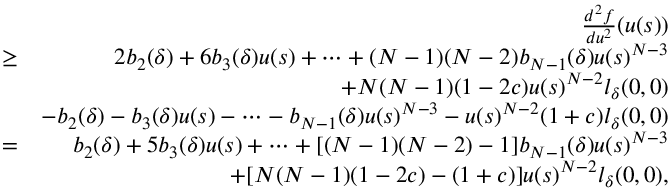Convert formula to latex. <formula><loc_0><loc_0><loc_500><loc_500>\begin{array} { r l r } & { \frac { d ^ { 2 } f } { d u ^ { 2 } } ( u ( s ) ) } \\ & { \geq } & { 2 b _ { 2 } ( \delta ) + 6 b _ { 3 } ( \delta ) u ( s ) + \cdots + ( N - 1 ) ( N - 2 ) b _ { N - 1 } ( \delta ) u ( s ) ^ { N - 3 } } \\ & { + N ( N - 1 ) ( 1 - 2 c ) u ( s ) ^ { N - 2 } l _ { \delta } ( 0 , 0 ) } \\ & { - b _ { 2 } ( \delta ) - b _ { 3 } ( \delta ) u ( s ) - \cdots - b _ { N - 1 } ( \delta ) u ( s ) ^ { N - 3 } - u ( s ) ^ { N - 2 } ( 1 + c ) l _ { \delta } ( 0 , 0 ) } \\ & { = } & { b _ { 2 } ( \delta ) + 5 b _ { 3 } ( \delta ) u ( s ) + \cdots + [ ( N - 1 ) ( N - 2 ) - 1 ] b _ { N - 1 } ( \delta ) u ( s ) ^ { N - 3 } } \\ & { + [ N ( N - 1 ) ( 1 - 2 c ) - ( 1 + c ) ] u ( s ) ^ { N - 2 } l _ { \delta } ( 0 , 0 ) , } \end{array}</formula> 